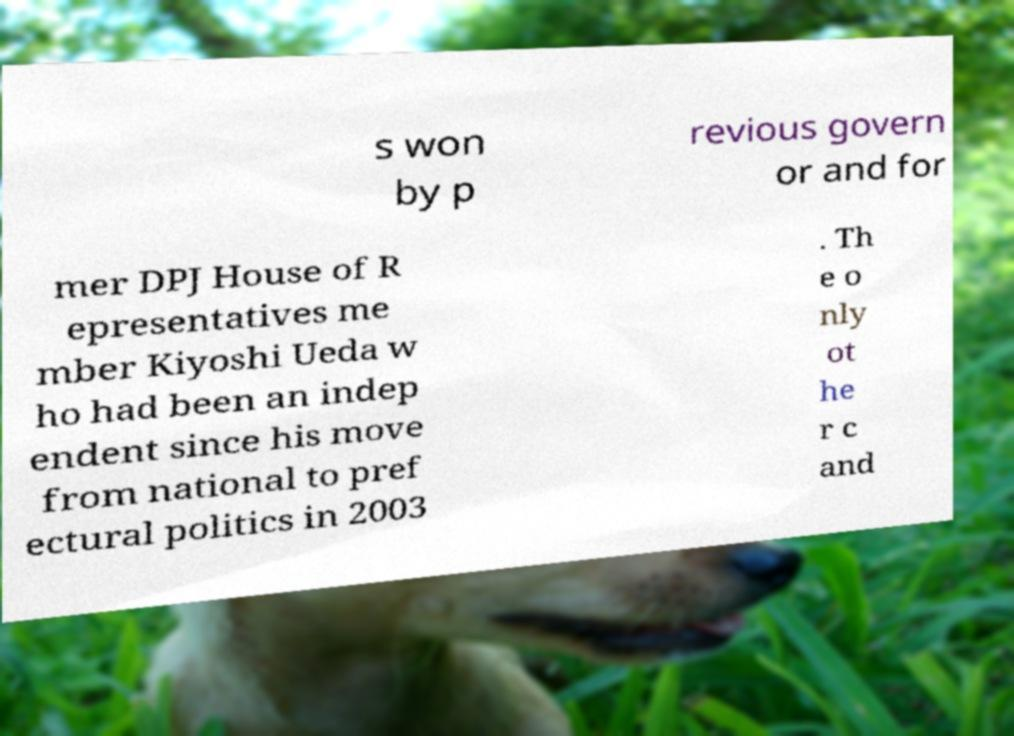There's text embedded in this image that I need extracted. Can you transcribe it verbatim? s won by p revious govern or and for mer DPJ House of R epresentatives me mber Kiyoshi Ueda w ho had been an indep endent since his move from national to pref ectural politics in 2003 . Th e o nly ot he r c and 